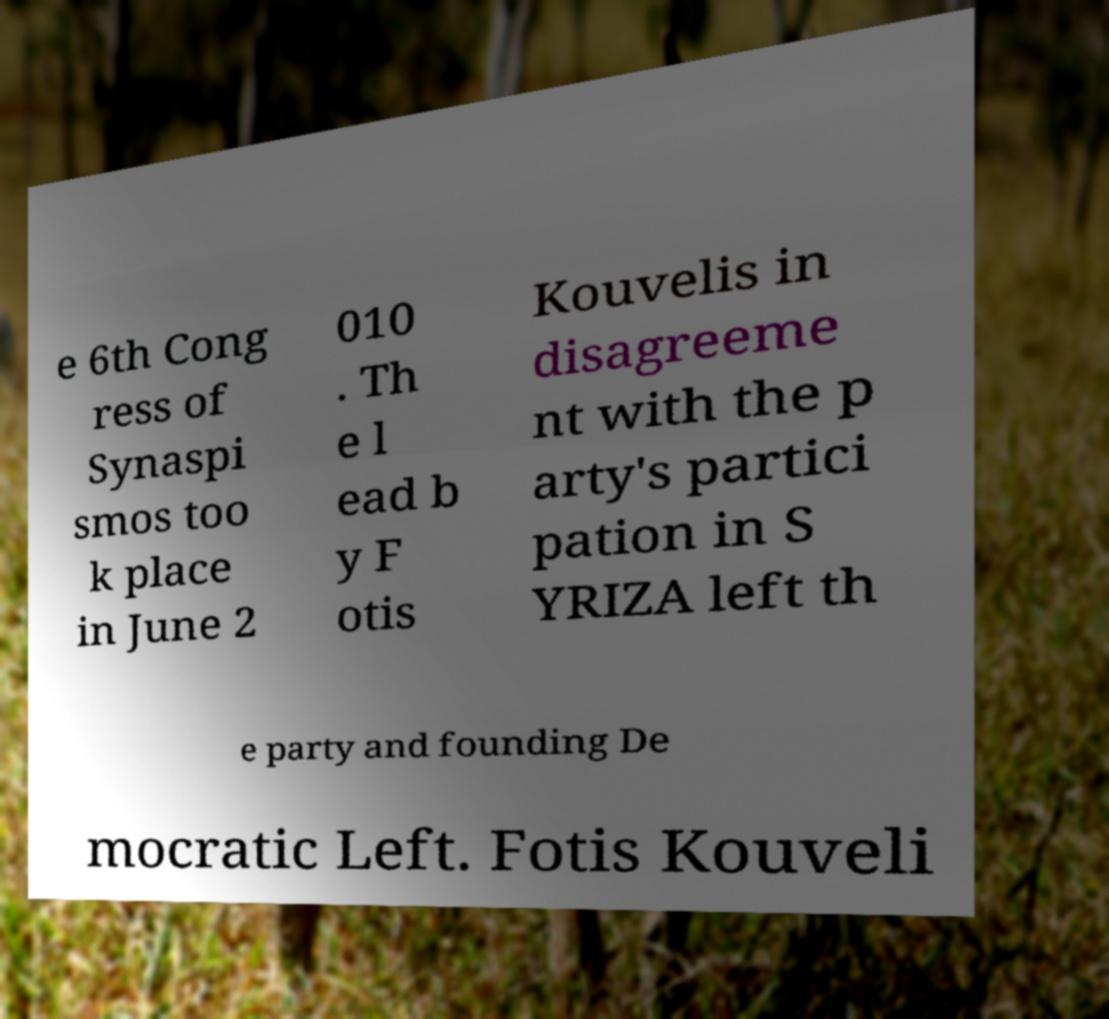Could you extract and type out the text from this image? e 6th Cong ress of Synaspi smos too k place in June 2 010 . Th e l ead b y F otis Kouvelis in disagreeme nt with the p arty's partici pation in S YRIZA left th e party and founding De mocratic Left. Fotis Kouveli 